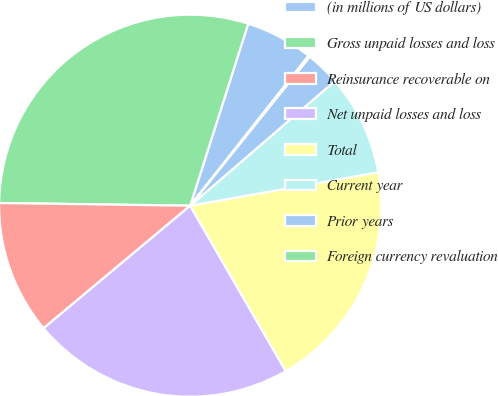Convert chart to OTSL. <chart><loc_0><loc_0><loc_500><loc_500><pie_chart><fcel>(in millions of US dollars)<fcel>Gross unpaid losses and loss<fcel>Reinsurance recoverable on<fcel>Net unpaid losses and loss<fcel>Total<fcel>Current year<fcel>Prior years<fcel>Foreign currency revaluation<nl><fcel>5.72%<fcel>29.69%<fcel>11.31%<fcel>22.26%<fcel>19.46%<fcel>8.52%<fcel>2.92%<fcel>0.13%<nl></chart> 